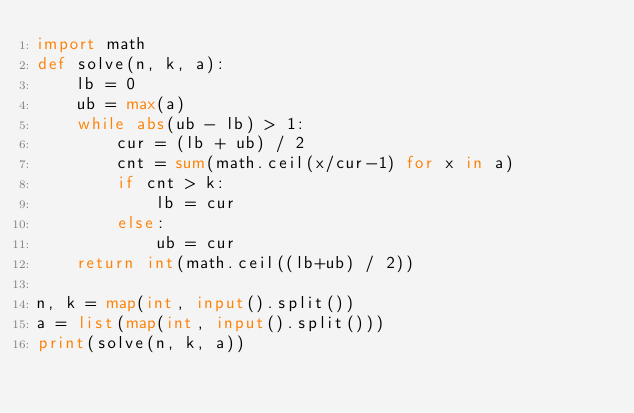<code> <loc_0><loc_0><loc_500><loc_500><_Python_>import math
def solve(n, k, a):
    lb = 0
    ub = max(a)
    while abs(ub - lb) > 1:
        cur = (lb + ub) / 2
        cnt = sum(math.ceil(x/cur-1) for x in a)
        if cnt > k:
            lb = cur
        else:
            ub = cur
    return int(math.ceil((lb+ub) / 2))

n, k = map(int, input().split())
a = list(map(int, input().split()))
print(solve(n, k, a))</code> 